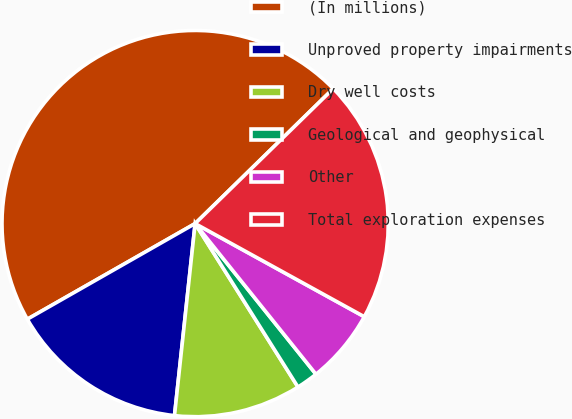<chart> <loc_0><loc_0><loc_500><loc_500><pie_chart><fcel>(In millions)<fcel>Unproved property impairments<fcel>Dry well costs<fcel>Geological and geophysical<fcel>Other<fcel>Total exploration expenses<nl><fcel>45.92%<fcel>15.05%<fcel>10.64%<fcel>1.82%<fcel>6.23%<fcel>20.32%<nl></chart> 